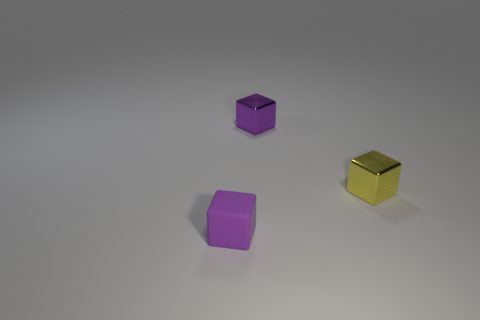Subtract all purple blocks. How many were subtracted if there are1purple blocks left? 1 Add 2 small purple matte blocks. How many objects exist? 5 Subtract all tiny yellow metal objects. Subtract all tiny blue things. How many objects are left? 2 Add 1 purple cubes. How many purple cubes are left? 3 Add 3 tiny purple rubber things. How many tiny purple rubber things exist? 4 Subtract 0 gray spheres. How many objects are left? 3 